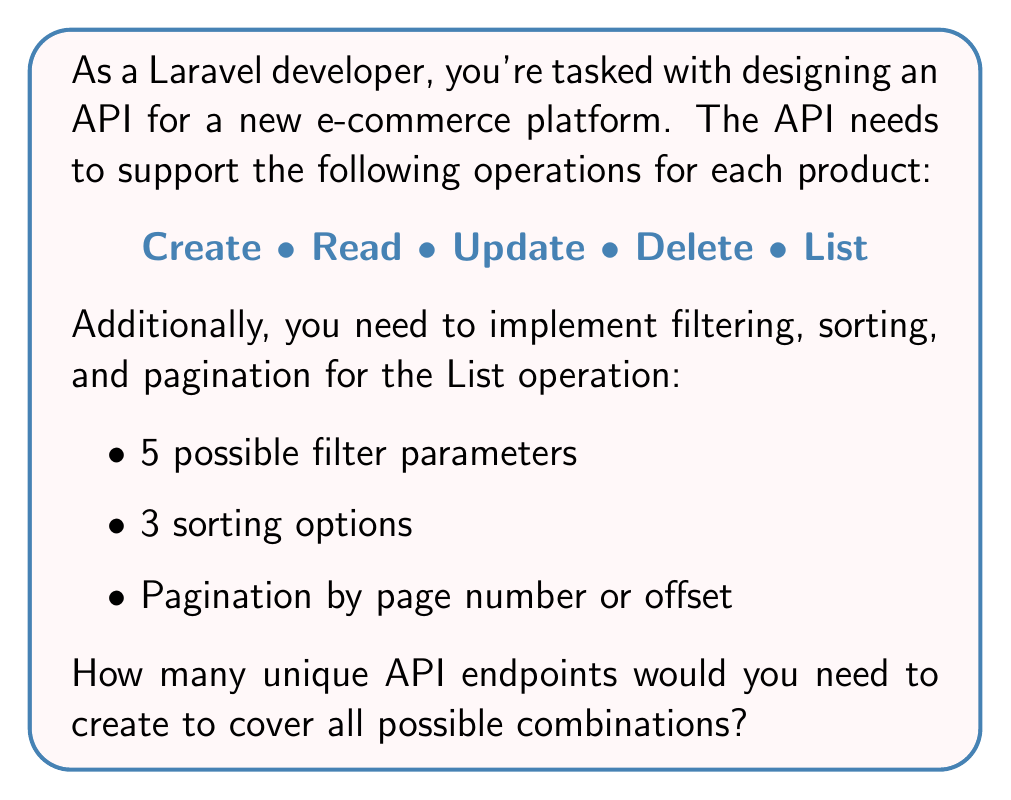Could you help me with this problem? Let's break this down step-by-step:

1) First, let's count the basic CRUD operations:
   - Create: 1 endpoint
   - Read: 1 endpoint
   - Update: 1 endpoint
   - Delete: 1 endpoint
   
   Subtotal: 4 endpoints

2) Now, let's focus on the List operation with its variations:

   a) Filtering:
      - We have 5 possible filter parameters.
      - Each parameter can be either applied or not applied.
      - This gives us $2^5 = 32$ possible filter combinations.

   b) Sorting:
      - We have 3 sorting options.
      - Each sort can be in ascending or descending order.
      - This gives us $3 * 2 = 6$ possible sorting combinations.

   c) Pagination:
      - We can paginate by either page number or offset.
      - This gives us 2 pagination options.

3) To calculate the total number of List endpoints, we multiply these options:
   $$ 32 * 6 * 2 = 384 $$

4) Finally, we add this to our basic CRUD operations:
   $$ 384 + 4 = 388 $$

Therefore, to cover all possible combinations, we would need 388 unique API endpoints.
Answer: 388 endpoints 